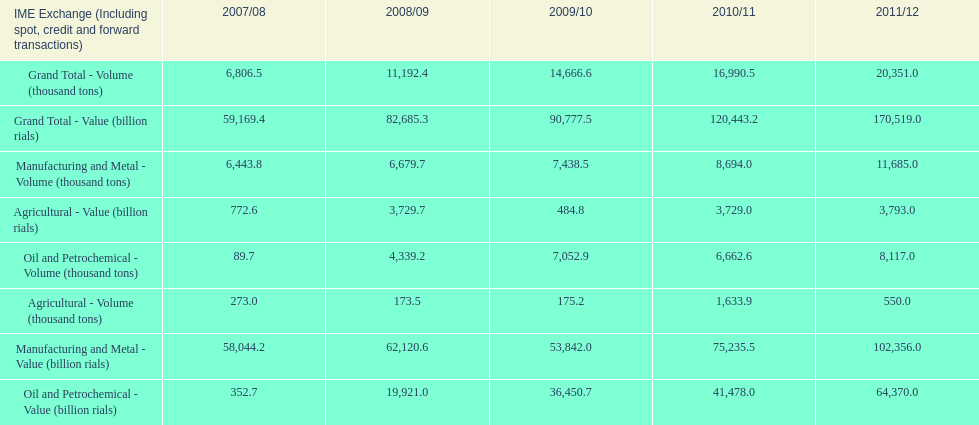What year saw the greatest value for manufacturing and metal in iran? 2011/12. 